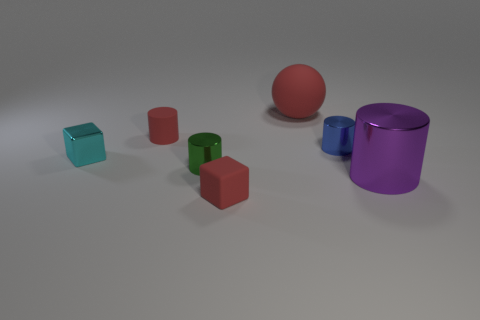Subtract all metallic cylinders. How many cylinders are left? 1 Subtract 1 cylinders. How many cylinders are left? 3 Add 1 small brown matte things. How many objects exist? 8 Subtract all purple cylinders. How many cylinders are left? 3 Subtract all blue cylinders. Subtract all purple blocks. How many cylinders are left? 3 Subtract all cubes. How many objects are left? 5 Add 6 cylinders. How many cylinders exist? 10 Subtract 0 yellow blocks. How many objects are left? 7 Subtract all big blue metal spheres. Subtract all large purple shiny cylinders. How many objects are left? 6 Add 3 tiny rubber things. How many tiny rubber things are left? 5 